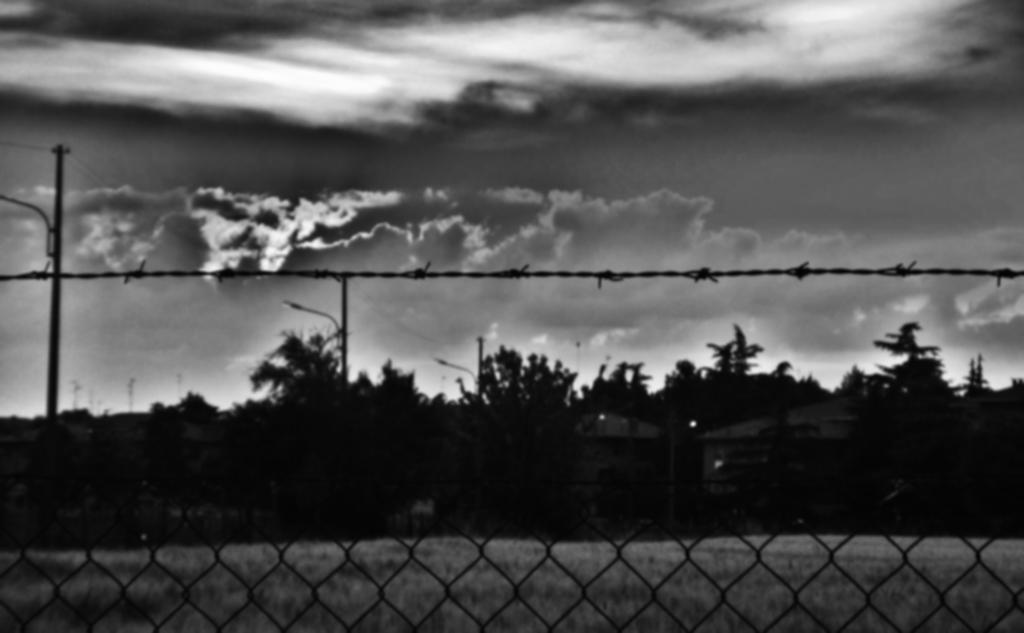What is located in the foreground of the image? There is fencing in the foreground of the image. What can be seen in the middle of the image? There are trees and a pole in the middle of the image, along with cables. What is visible in the background of the image? The sky is visible in the background of the image. What type of board game is being played by the mom in the image? There is no mom or board game present in the image. What is the color of the copper wire visible in the image? There is no copper wire present in the image. 